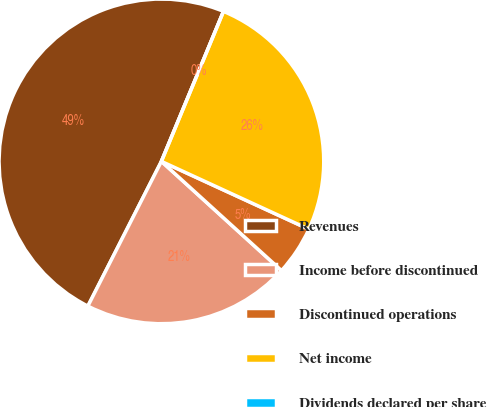Convert chart. <chart><loc_0><loc_0><loc_500><loc_500><pie_chart><fcel>Revenues<fcel>Income before discontinued<fcel>Discontinued operations<fcel>Net income<fcel>Dividends declared per share<nl><fcel>48.77%<fcel>20.74%<fcel>4.88%<fcel>25.62%<fcel>0.0%<nl></chart> 